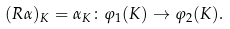<formula> <loc_0><loc_0><loc_500><loc_500>( R \alpha ) _ { K } = \alpha _ { K } \colon \varphi _ { 1 } ( K ) \rightarrow \varphi _ { 2 } ( K ) .</formula> 